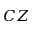<formula> <loc_0><loc_0><loc_500><loc_500>C Z</formula> 